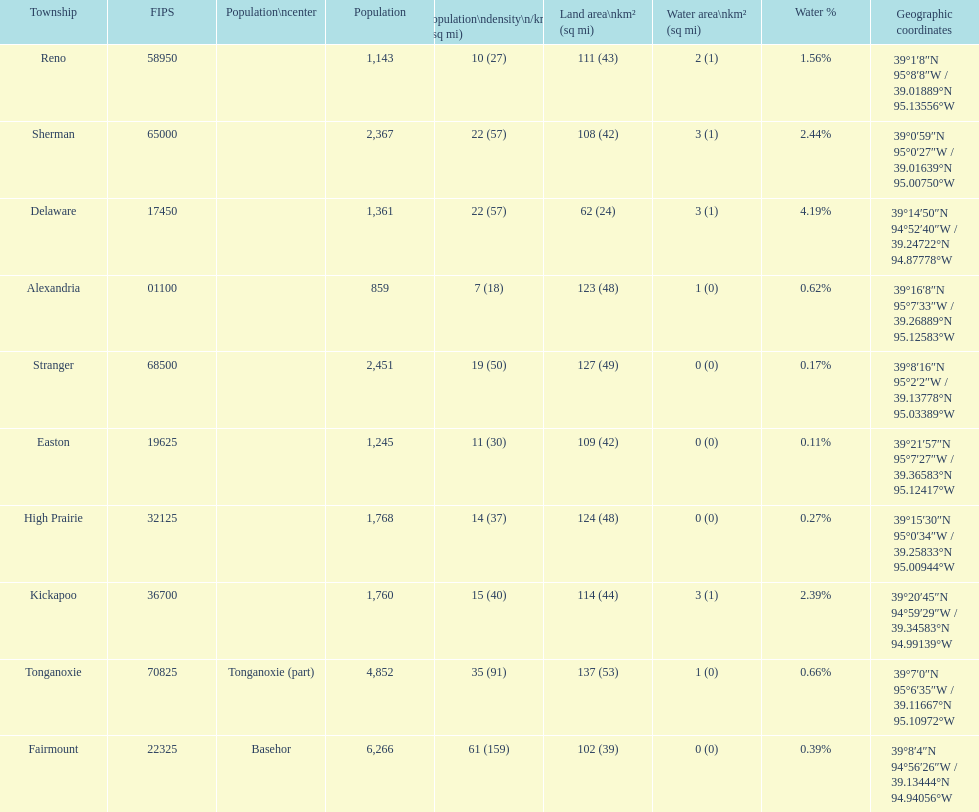What is the difference of population in easton and reno? 102. 